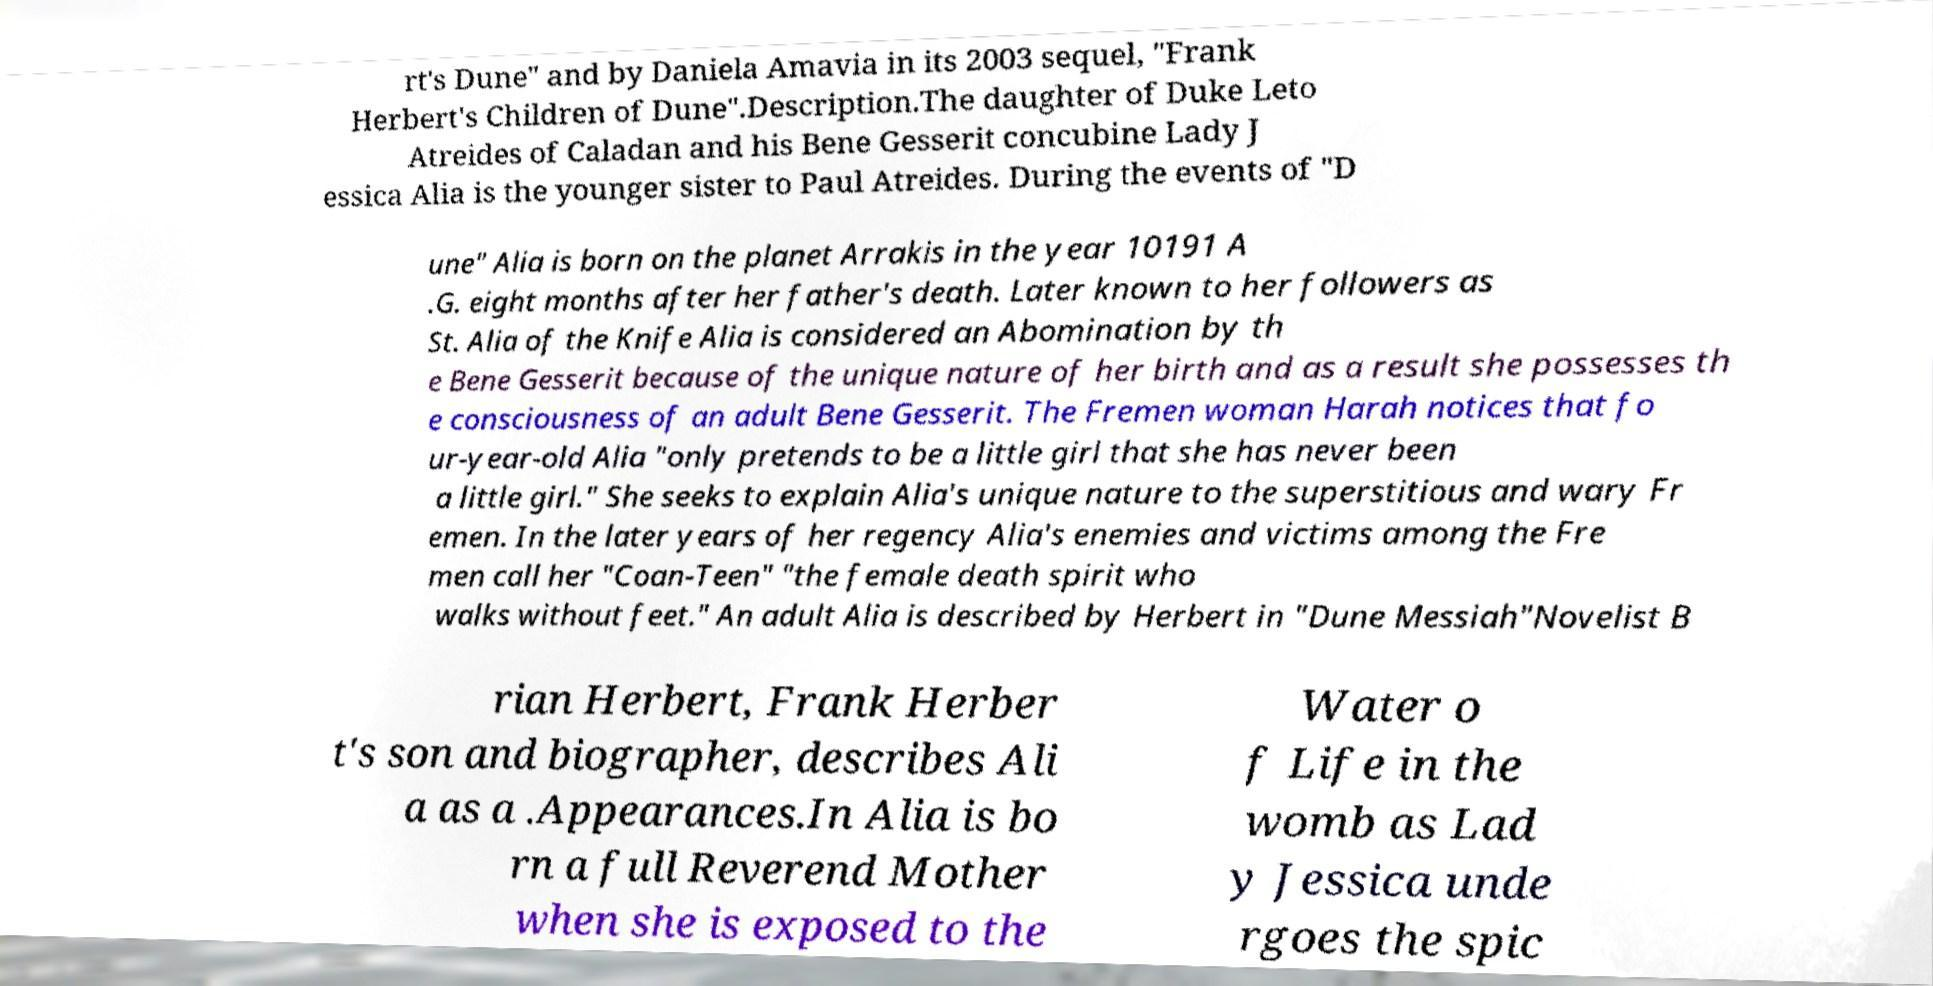Could you assist in decoding the text presented in this image and type it out clearly? rt's Dune" and by Daniela Amavia in its 2003 sequel, "Frank Herbert's Children of Dune".Description.The daughter of Duke Leto Atreides of Caladan and his Bene Gesserit concubine Lady J essica Alia is the younger sister to Paul Atreides. During the events of "D une" Alia is born on the planet Arrakis in the year 10191 A .G. eight months after her father's death. Later known to her followers as St. Alia of the Knife Alia is considered an Abomination by th e Bene Gesserit because of the unique nature of her birth and as a result she possesses th e consciousness of an adult Bene Gesserit. The Fremen woman Harah notices that fo ur-year-old Alia "only pretends to be a little girl that she has never been a little girl." She seeks to explain Alia's unique nature to the superstitious and wary Fr emen. In the later years of her regency Alia's enemies and victims among the Fre men call her "Coan-Teen" "the female death spirit who walks without feet." An adult Alia is described by Herbert in "Dune Messiah"Novelist B rian Herbert, Frank Herber t's son and biographer, describes Ali a as a .Appearances.In Alia is bo rn a full Reverend Mother when she is exposed to the Water o f Life in the womb as Lad y Jessica unde rgoes the spic 